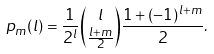Convert formula to latex. <formula><loc_0><loc_0><loc_500><loc_500>p _ { m } ( l ) = \frac { 1 } { 2 ^ { l } } { l \choose \frac { l + m } { 2 } } \frac { 1 + ( - 1 ) ^ { l + m } } { 2 } .</formula> 